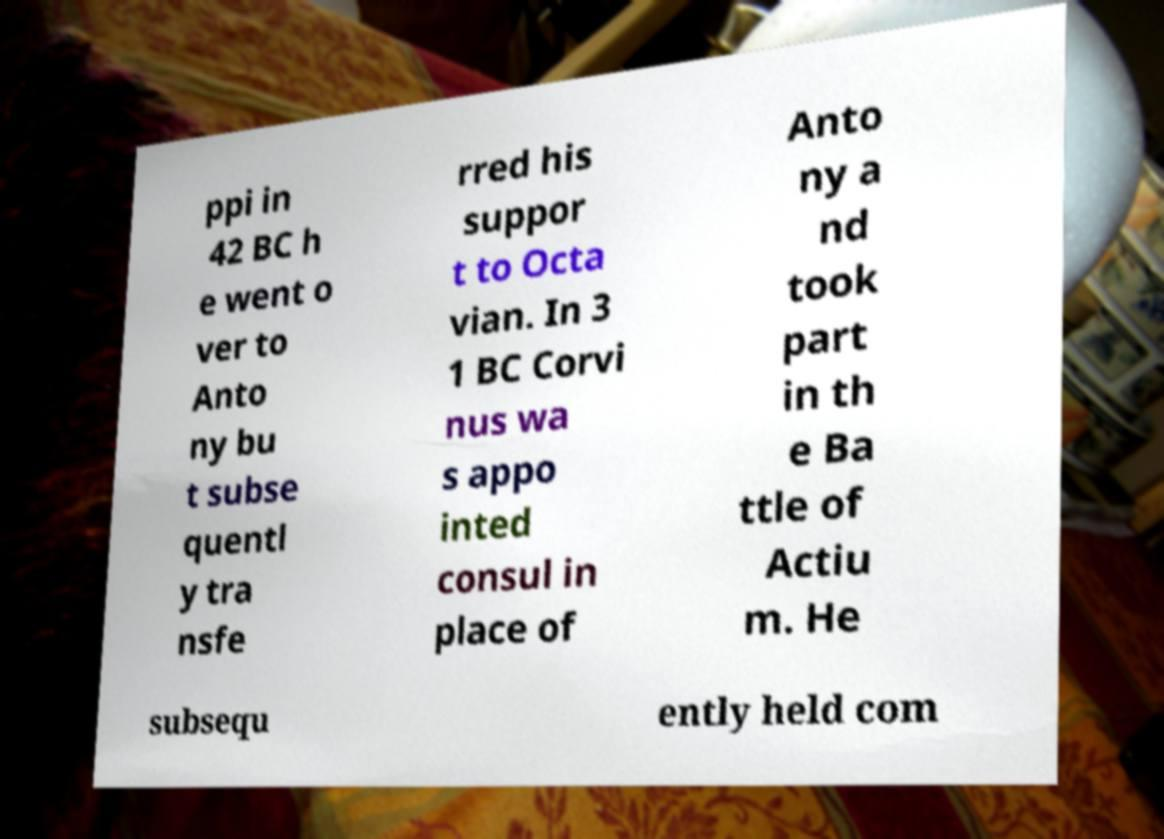Can you read and provide the text displayed in the image?This photo seems to have some interesting text. Can you extract and type it out for me? ppi in 42 BC h e went o ver to Anto ny bu t subse quentl y tra nsfe rred his suppor t to Octa vian. In 3 1 BC Corvi nus wa s appo inted consul in place of Anto ny a nd took part in th e Ba ttle of Actiu m. He subsequ ently held com 